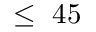<formula> <loc_0><loc_0><loc_500><loc_500>\leq 4 5</formula> 